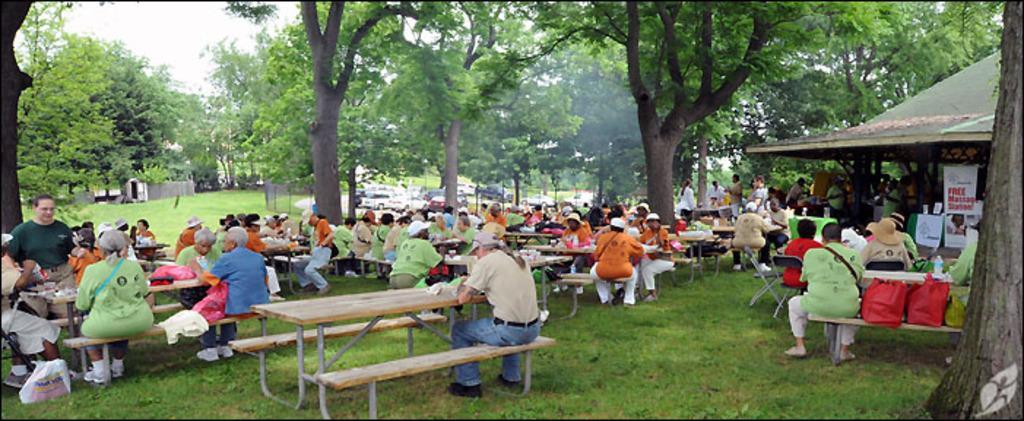Can you describe this image briefly? In this picture there is a woman who is wearing t-shirt, jeans and shoe. She is sitting on the table and eating some food. Here we can see group of persons are sitting on the bench and doing some work with plastic covers. On the right there is a man who is wearing green t-shirt, trouser and shoe. He is sitting beside the red and green color bag. On the background we can see three persons standing near to the table. Here we can see group of persons who are under the shed. On the top we can see many trees. On the top there is a sky. On the background we can see cars which is near to the fencing. On the left background there is a room. On the bottom we can see grass. 